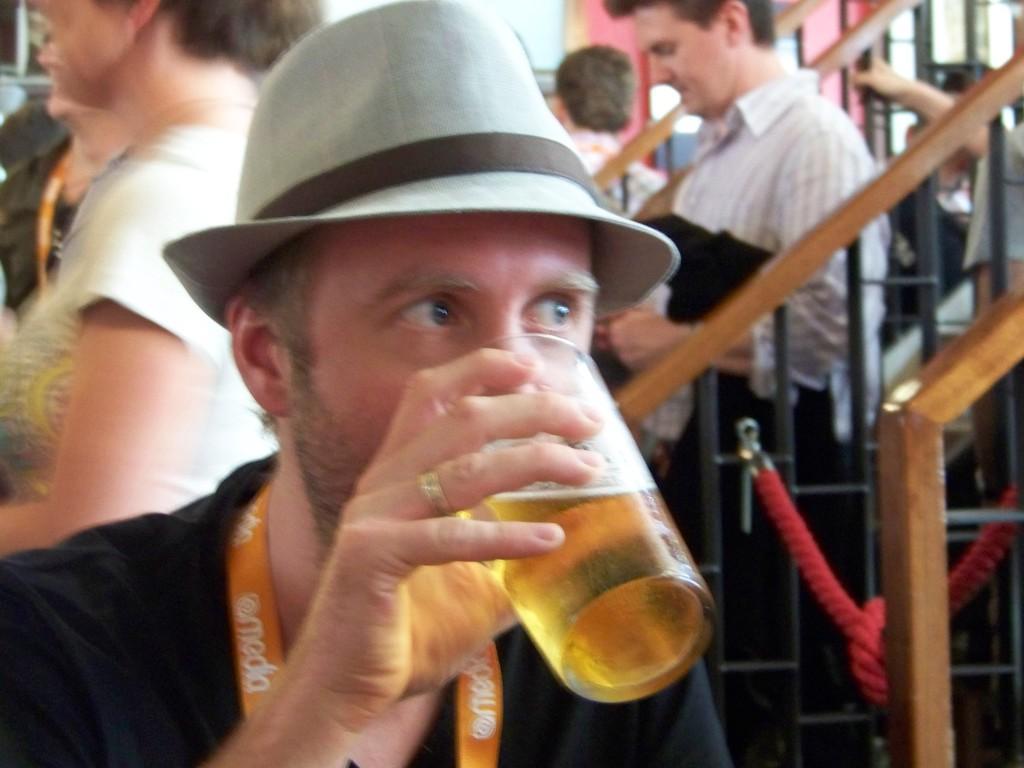Could you give a brief overview of what you see in this image? In the image we can see there are people who are standing at the back and in front there is a man who is sitting and holding a glass in which there is a wine and he is wearing a cap. 